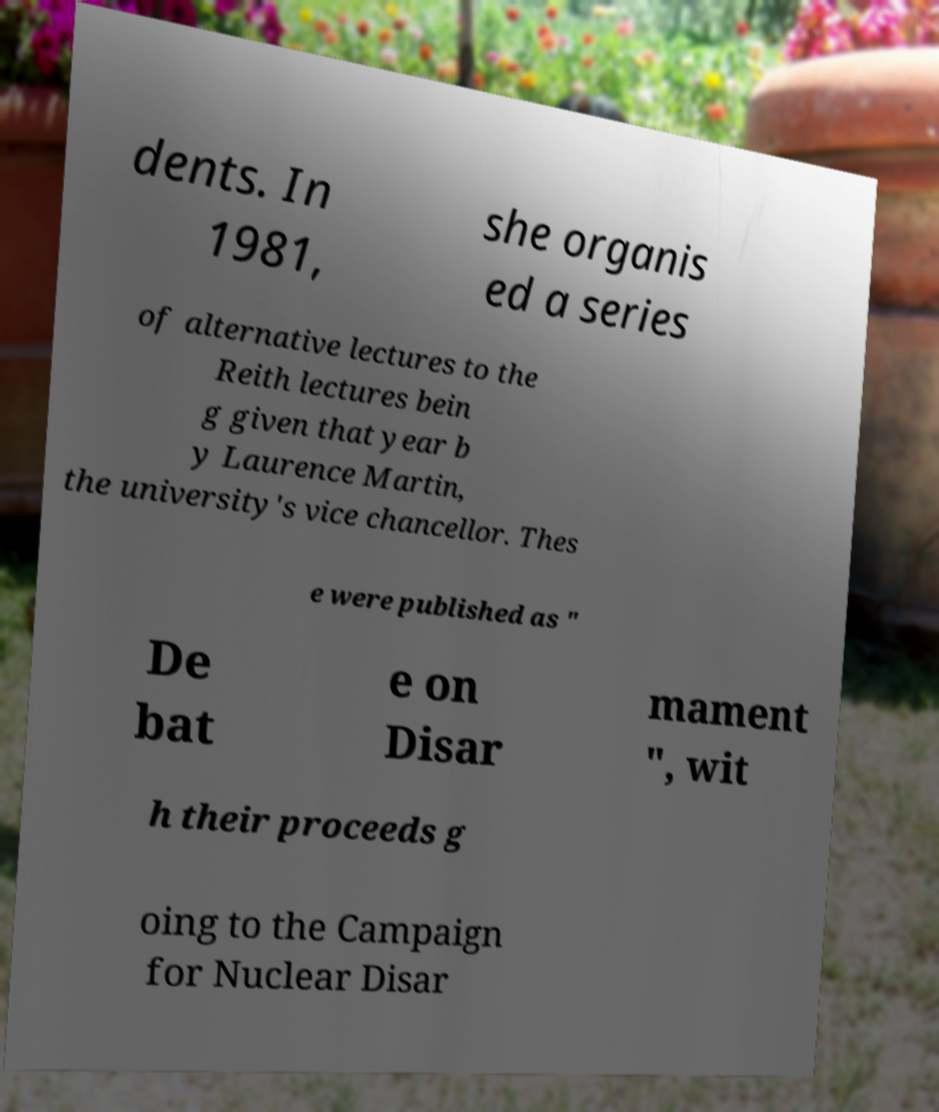What messages or text are displayed in this image? I need them in a readable, typed format. dents. In 1981, she organis ed a series of alternative lectures to the Reith lectures bein g given that year b y Laurence Martin, the university's vice chancellor. Thes e were published as " De bat e on Disar mament ", wit h their proceeds g oing to the Campaign for Nuclear Disar 